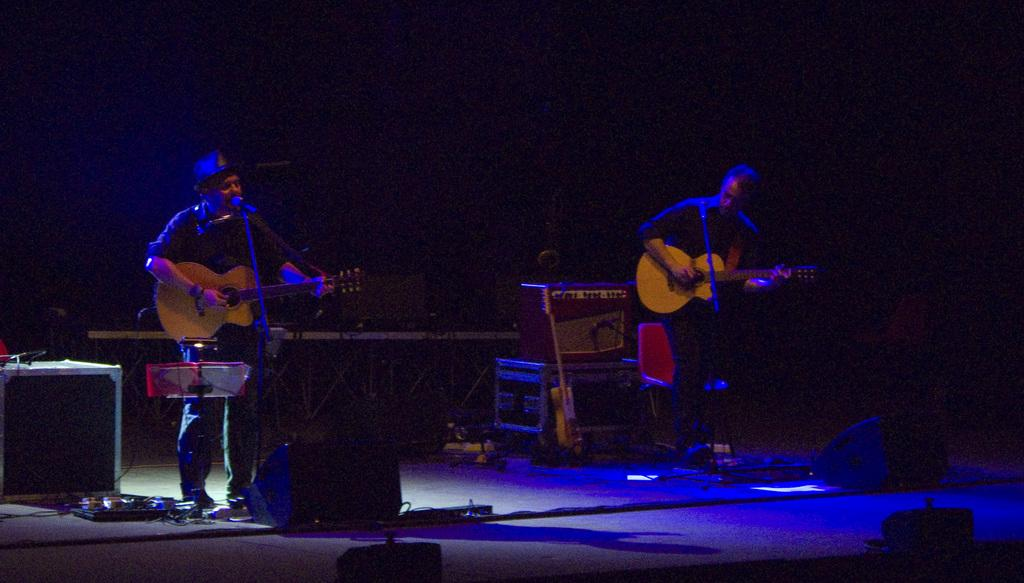How many people are in the image? There are two men in the image. What are the men doing in the image? The men are playing guitars. What object is present in the image that is commonly used for amplifying sound? There is a microphone in the image. Where does the scene take place? The scene takes place on a stage. What type of root can be seen growing from the guitar in the image? There is no root growing from the guitar in the image; it is a musical instrument being played by the men. 